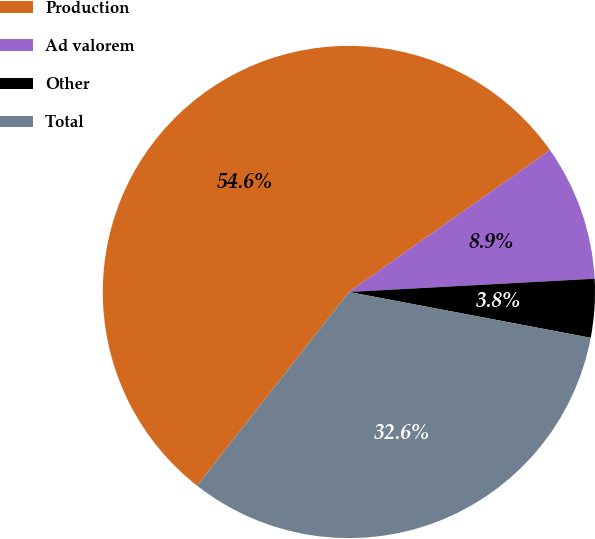Convert chart. <chart><loc_0><loc_0><loc_500><loc_500><pie_chart><fcel>Production<fcel>Ad valorem<fcel>Other<fcel>Total<nl><fcel>54.65%<fcel>8.92%<fcel>3.84%<fcel>32.6%<nl></chart> 